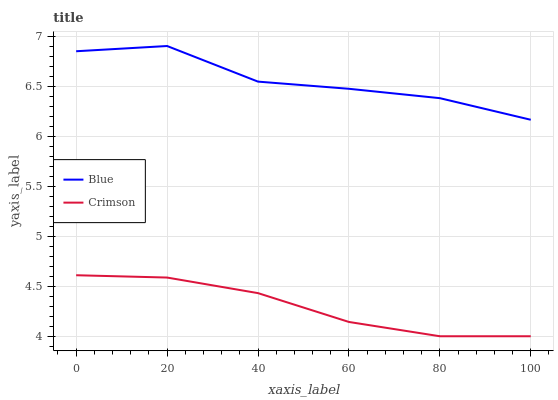Does Crimson have the minimum area under the curve?
Answer yes or no. Yes. Does Blue have the maximum area under the curve?
Answer yes or no. Yes. Does Crimson have the maximum area under the curve?
Answer yes or no. No. Is Crimson the smoothest?
Answer yes or no. Yes. Is Blue the roughest?
Answer yes or no. Yes. Is Crimson the roughest?
Answer yes or no. No. Does Crimson have the lowest value?
Answer yes or no. Yes. Does Blue have the highest value?
Answer yes or no. Yes. Does Crimson have the highest value?
Answer yes or no. No. Is Crimson less than Blue?
Answer yes or no. Yes. Is Blue greater than Crimson?
Answer yes or no. Yes. Does Crimson intersect Blue?
Answer yes or no. No. 